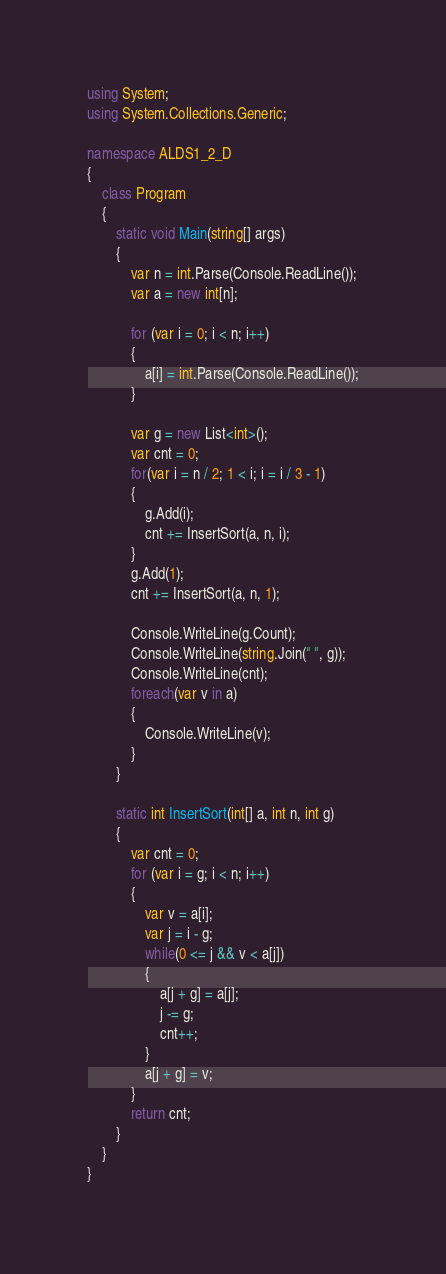Convert code to text. <code><loc_0><loc_0><loc_500><loc_500><_C#_>using System;
using System.Collections.Generic;

namespace ALDS1_2_D
{
	class Program
	{
		static void Main(string[] args)
		{
			var n = int.Parse(Console.ReadLine());
			var a = new int[n];

			for (var i = 0; i < n; i++)
			{
				a[i] = int.Parse(Console.ReadLine());
			}

			var g = new List<int>();
			var cnt = 0;
			for(var i = n / 2; 1 < i; i = i / 3 - 1)
			{
				g.Add(i);
				cnt += InsertSort(a, n, i);
			}
			g.Add(1);
			cnt += InsertSort(a, n, 1);

			Console.WriteLine(g.Count);
			Console.WriteLine(string.Join(" ", g));
			Console.WriteLine(cnt);
			foreach(var v in a)
			{
				Console.WriteLine(v);
			}
		}

		static int InsertSort(int[] a, int n, int g)
		{
			var cnt = 0;
			for (var i = g; i < n; i++)
			{
				var v = a[i];
				var j = i - g;
				while(0 <= j && v < a[j])
				{
					a[j + g] = a[j];
					j -= g;
					cnt++;
				}
				a[j + g] = v;
			}
			return cnt;
		}
	}
}

</code> 